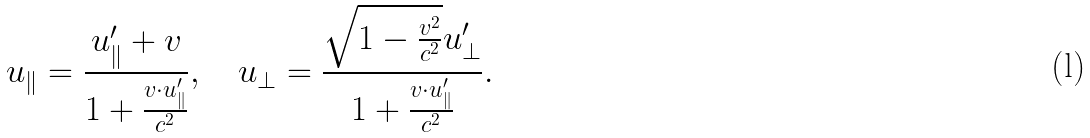Convert formula to latex. <formula><loc_0><loc_0><loc_500><loc_500>u _ { \| } = { \frac { u _ { \| } ^ { \prime } + v } { 1 + { \frac { v \cdot u _ { \| } ^ { \prime } } { c ^ { 2 } } } } } , \quad u _ { \perp } = { \frac { { \sqrt { 1 - { \frac { v ^ { 2 } } { c ^ { 2 } } } } } u _ { \perp } ^ { \prime } } { 1 + { \frac { v \cdot u _ { \| } ^ { \prime } } { c ^ { 2 } } } } } .</formula> 